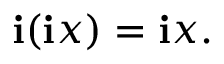Convert formula to latex. <formula><loc_0><loc_0><loc_500><loc_500>i ( i x ) = i x .</formula> 